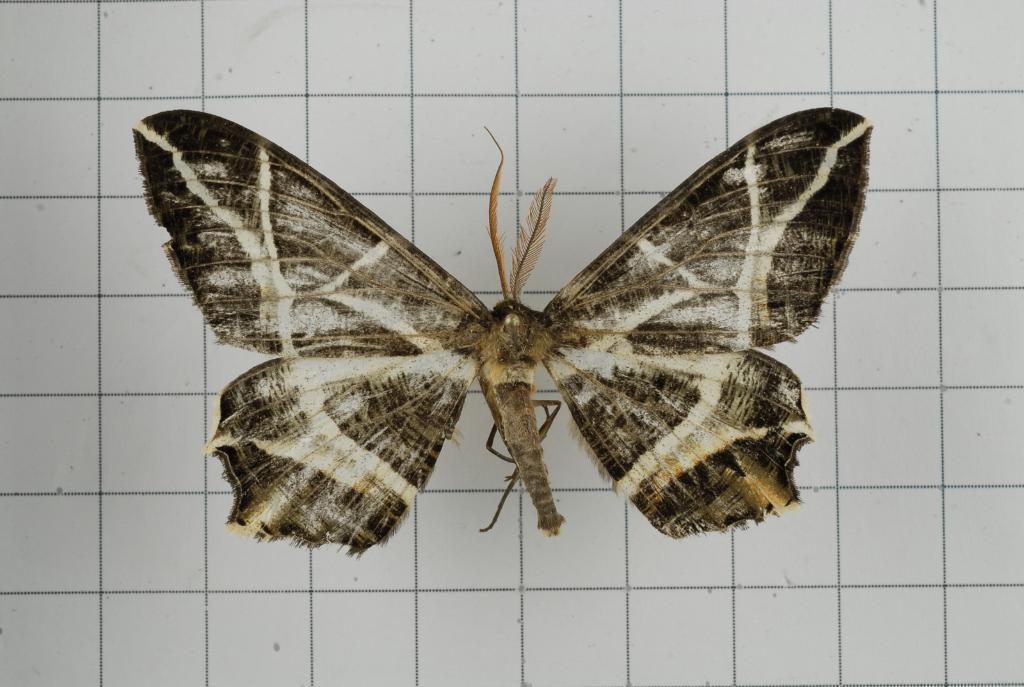What is present on the white wall in the image? There is an insect on the white wall in the image. What type of cushion is visible in the image? There is no cushion present in the image. What color is the oatmeal in the image? There is no oatmeal present in the image. 